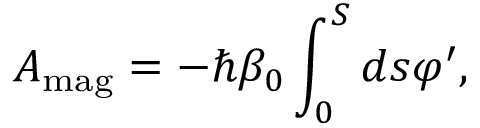<formula> <loc_0><loc_0><loc_500><loc_500>A _ { m a g } = - \hbar { \beta } _ { 0 } \int _ { 0 } ^ { S } d s \varphi ^ { \prime } ,</formula> 